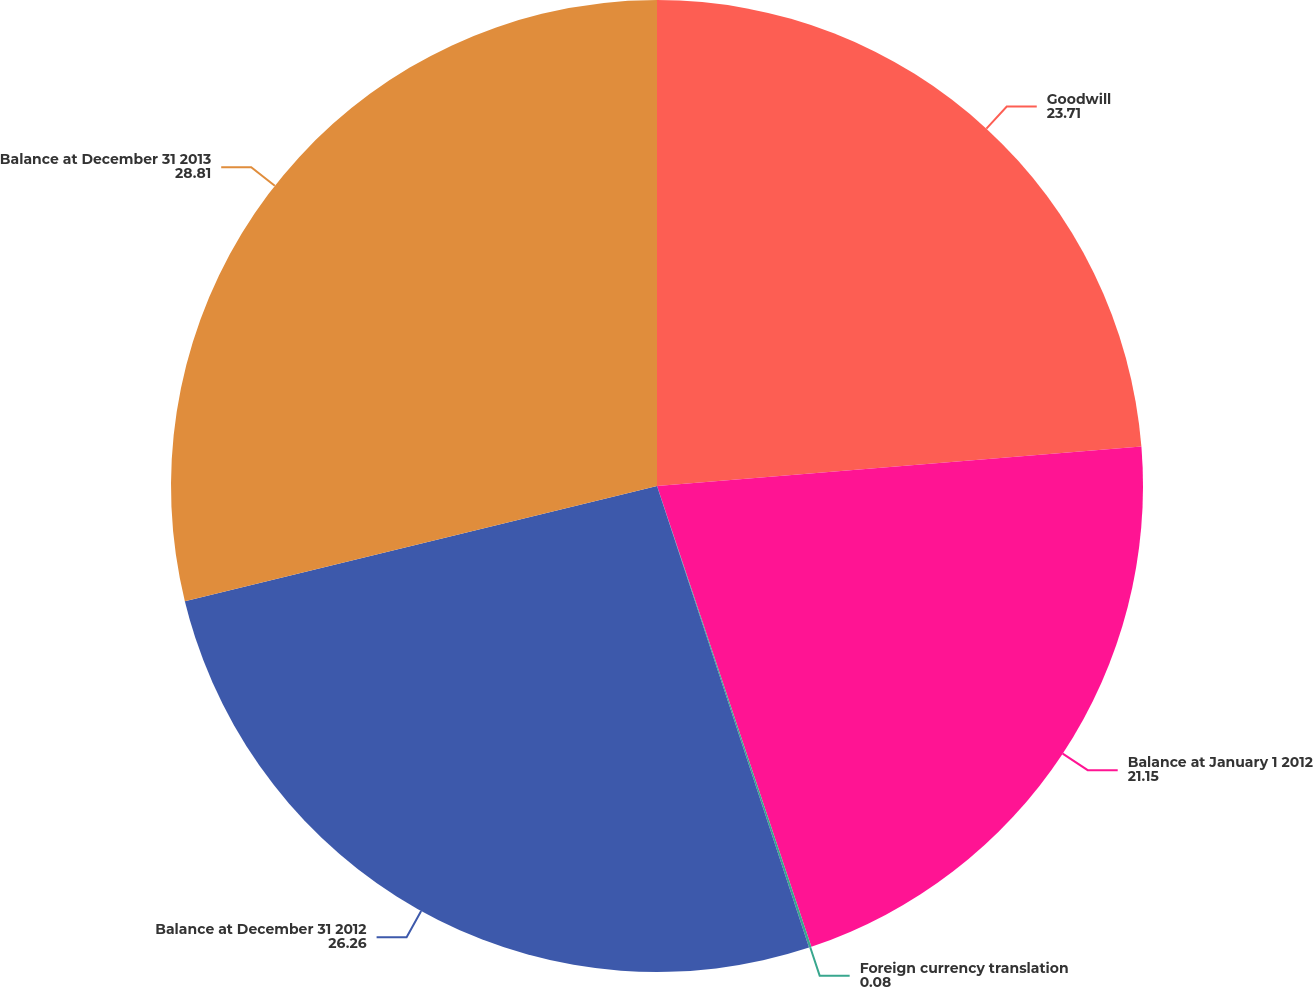<chart> <loc_0><loc_0><loc_500><loc_500><pie_chart><fcel>Goodwill<fcel>Balance at January 1 2012<fcel>Foreign currency translation<fcel>Balance at December 31 2012<fcel>Balance at December 31 2013<nl><fcel>23.71%<fcel>21.15%<fcel>0.08%<fcel>26.26%<fcel>28.81%<nl></chart> 